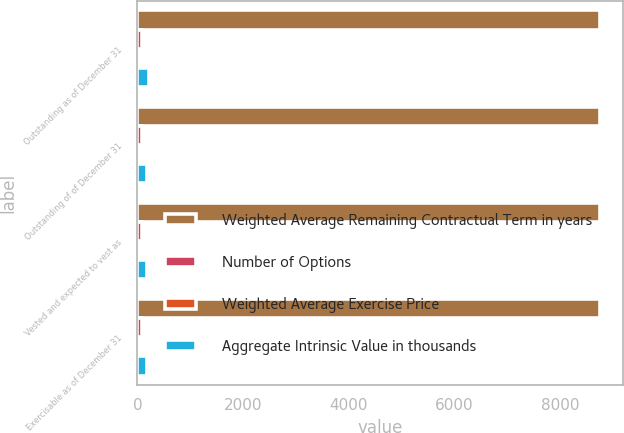Convert chart to OTSL. <chart><loc_0><loc_0><loc_500><loc_500><stacked_bar_chart><ecel><fcel>Outstanding as of December 31<fcel>Outstanding of of December 31<fcel>Vested and expected to vest as<fcel>Exercisable as of December 31<nl><fcel>Weighted Average Remaining Contractual Term in years<fcel>8741<fcel>8741<fcel>8741<fcel>8741<nl><fcel>Number of Options<fcel>88.45<fcel>88.45<fcel>88.45<fcel>88.45<nl><fcel>Weighted Average Exercise Price<fcel>2.1<fcel>1.1<fcel>1.1<fcel>1.1<nl><fcel>Aggregate Intrinsic Value in thousands<fcel>216<fcel>178<fcel>178<fcel>178<nl></chart> 